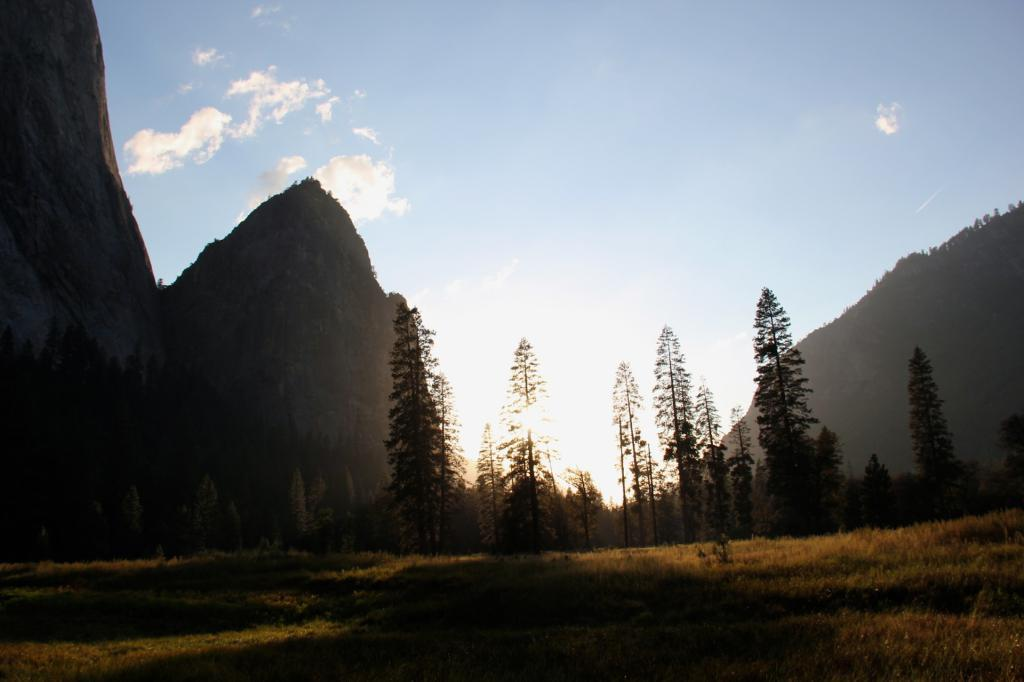What type of vegetation can be seen in the image? There are trees, plants, and grass visible in the image. What type of landscape feature is present in the image? There are hills in the image. What is visible in the background of the image? The sky is visible in the image, and there are clouds present. What type of scent can be detected from the cemetery in the image? There is no cemetery present in the image, so it is not possible to determine any scent associated with it. 